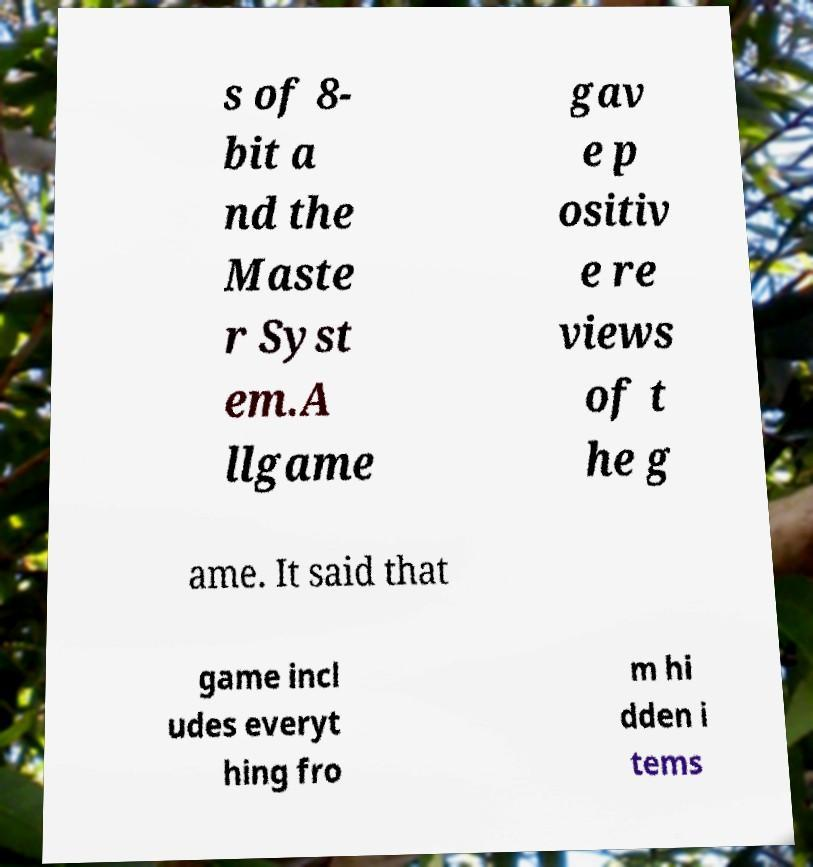For documentation purposes, I need the text within this image transcribed. Could you provide that? s of 8- bit a nd the Maste r Syst em.A llgame gav e p ositiv e re views of t he g ame. It said that game incl udes everyt hing fro m hi dden i tems 